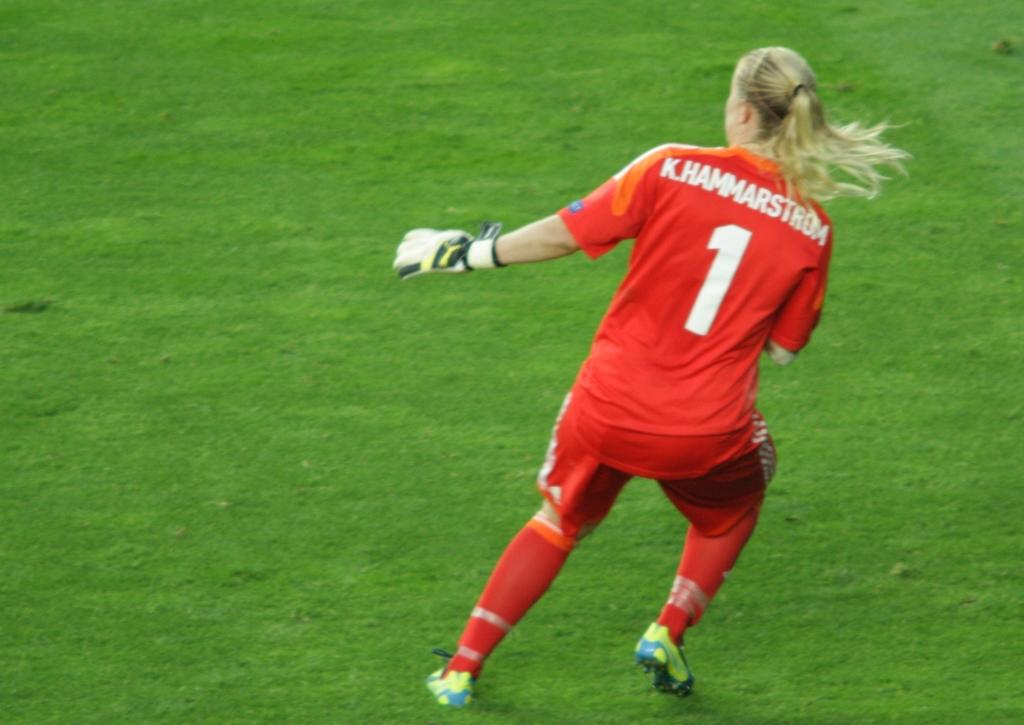What is the main subject of the image? There is a person in the image. Where is the person located in the image? The person is standing on the right side of the image. What is the person wearing? The person is wearing a red dress. What can be seen in the background of the image? There is a ground visible in the background of the image. What type of cattle can be seen grazing in the image? There are no cattle present in the image; it features a person standing on the right side of the image. What effect does the person's red dress have on the overall mood of the image? The provided facts do not mention the mood of the image, so it is not possible to determine the effect of the person's red dress on the mood. 